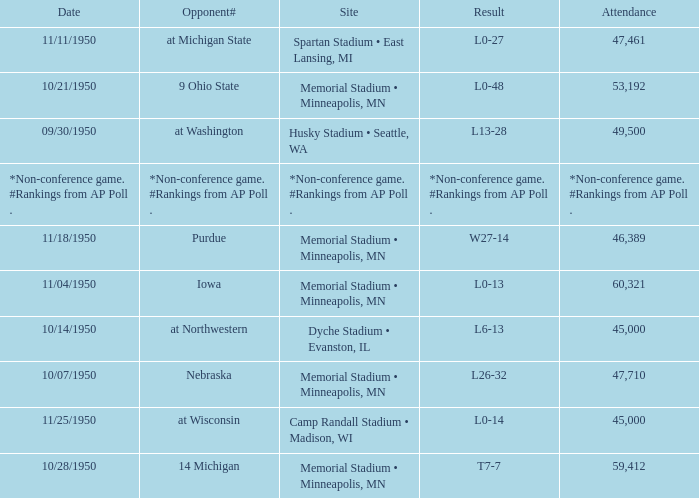What is the date when the opponent# is iowa? 11/04/1950. 